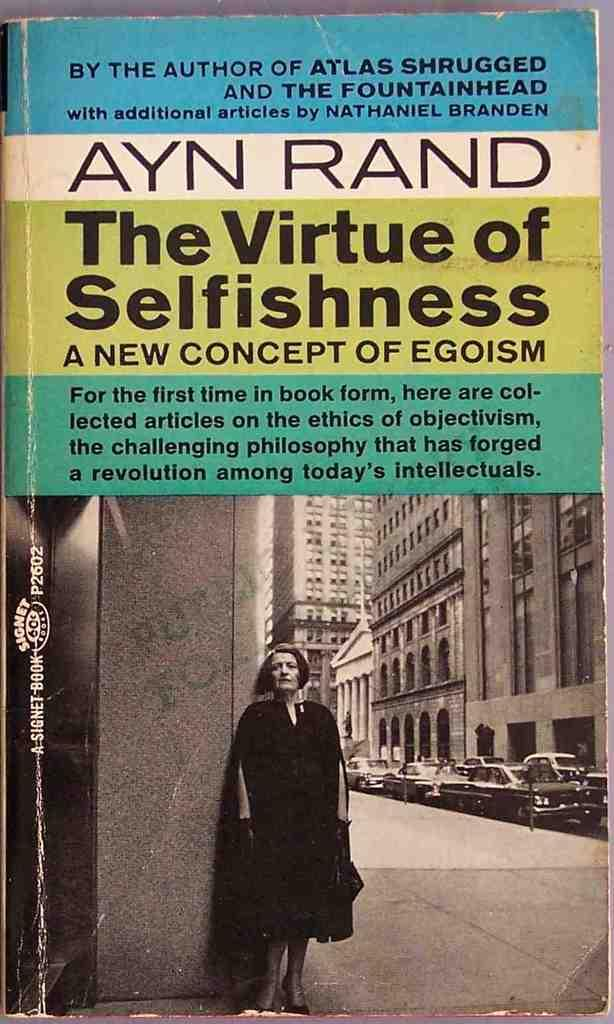<image>
Provide a brief description of the given image. Front cover of the book, The Virtue of Selfishness. 